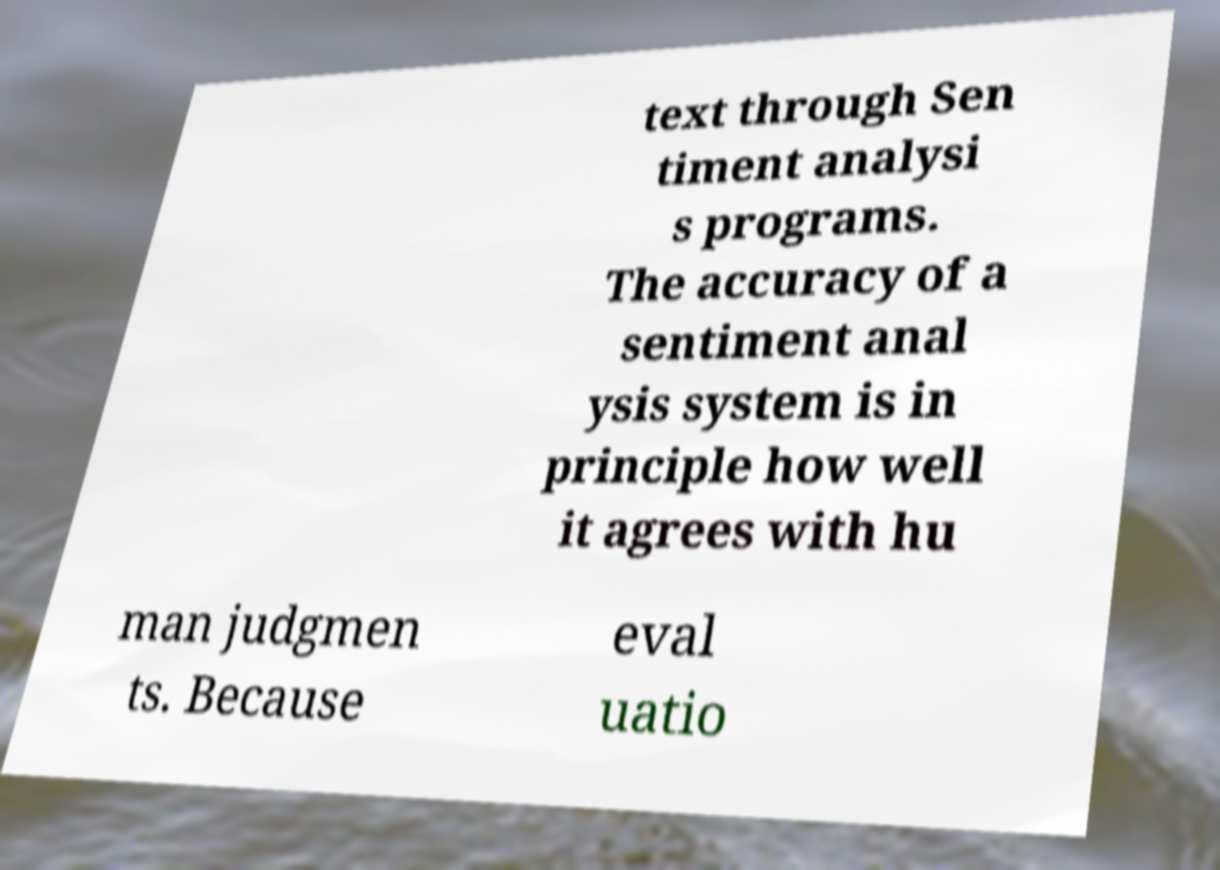Can you read and provide the text displayed in the image?This photo seems to have some interesting text. Can you extract and type it out for me? text through Sen timent analysi s programs. The accuracy of a sentiment anal ysis system is in principle how well it agrees with hu man judgmen ts. Because eval uatio 